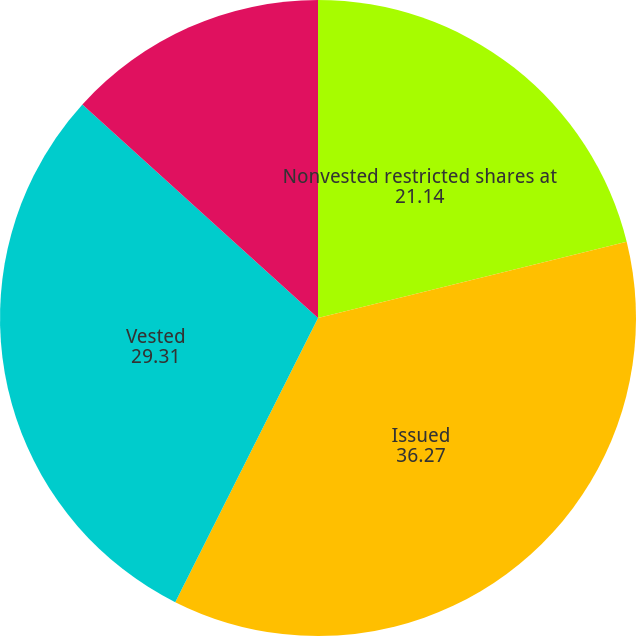Convert chart. <chart><loc_0><loc_0><loc_500><loc_500><pie_chart><fcel>Nonvested restricted shares at<fcel>Issued<fcel>Vested<fcel>Forfeited<nl><fcel>21.14%<fcel>36.27%<fcel>29.31%<fcel>13.28%<nl></chart> 